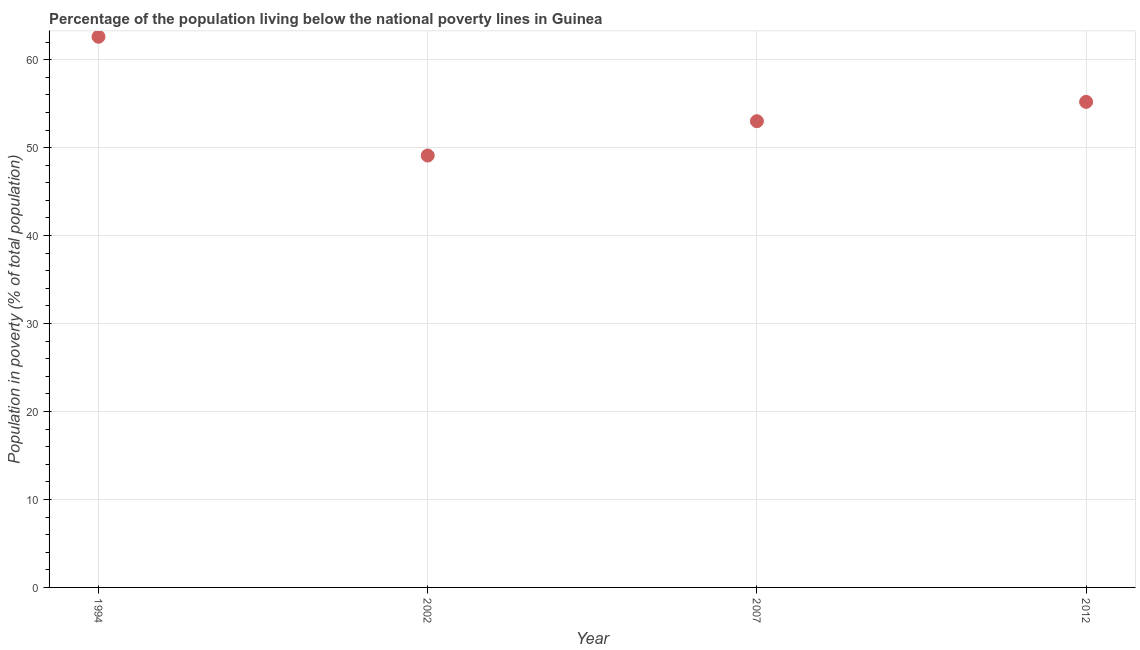What is the percentage of population living below poverty line in 1994?
Give a very brief answer. 62.6. Across all years, what is the maximum percentage of population living below poverty line?
Your response must be concise. 62.6. Across all years, what is the minimum percentage of population living below poverty line?
Make the answer very short. 49.1. In which year was the percentage of population living below poverty line maximum?
Keep it short and to the point. 1994. What is the sum of the percentage of population living below poverty line?
Your response must be concise. 219.9. What is the difference between the percentage of population living below poverty line in 2002 and 2012?
Offer a very short reply. -6.1. What is the average percentage of population living below poverty line per year?
Provide a short and direct response. 54.97. What is the median percentage of population living below poverty line?
Provide a succinct answer. 54.1. In how many years, is the percentage of population living below poverty line greater than 24 %?
Offer a very short reply. 4. Do a majority of the years between 2007 and 1994 (inclusive) have percentage of population living below poverty line greater than 6 %?
Provide a short and direct response. No. What is the ratio of the percentage of population living below poverty line in 2002 to that in 2012?
Give a very brief answer. 0.89. Is the difference between the percentage of population living below poverty line in 2007 and 2012 greater than the difference between any two years?
Give a very brief answer. No. What is the difference between the highest and the second highest percentage of population living below poverty line?
Offer a terse response. 7.4. In how many years, is the percentage of population living below poverty line greater than the average percentage of population living below poverty line taken over all years?
Provide a short and direct response. 2. How many dotlines are there?
Keep it short and to the point. 1. How many years are there in the graph?
Keep it short and to the point. 4. What is the title of the graph?
Provide a short and direct response. Percentage of the population living below the national poverty lines in Guinea. What is the label or title of the Y-axis?
Keep it short and to the point. Population in poverty (% of total population). What is the Population in poverty (% of total population) in 1994?
Keep it short and to the point. 62.6. What is the Population in poverty (% of total population) in 2002?
Your answer should be compact. 49.1. What is the Population in poverty (% of total population) in 2012?
Ensure brevity in your answer.  55.2. What is the difference between the Population in poverty (% of total population) in 1994 and 2002?
Ensure brevity in your answer.  13.5. What is the difference between the Population in poverty (% of total population) in 1994 and 2012?
Offer a very short reply. 7.4. What is the difference between the Population in poverty (% of total population) in 2002 and 2007?
Your answer should be very brief. -3.9. What is the ratio of the Population in poverty (% of total population) in 1994 to that in 2002?
Give a very brief answer. 1.27. What is the ratio of the Population in poverty (% of total population) in 1994 to that in 2007?
Ensure brevity in your answer.  1.18. What is the ratio of the Population in poverty (% of total population) in 1994 to that in 2012?
Keep it short and to the point. 1.13. What is the ratio of the Population in poverty (% of total population) in 2002 to that in 2007?
Your answer should be compact. 0.93. What is the ratio of the Population in poverty (% of total population) in 2002 to that in 2012?
Give a very brief answer. 0.89. What is the ratio of the Population in poverty (% of total population) in 2007 to that in 2012?
Provide a succinct answer. 0.96. 